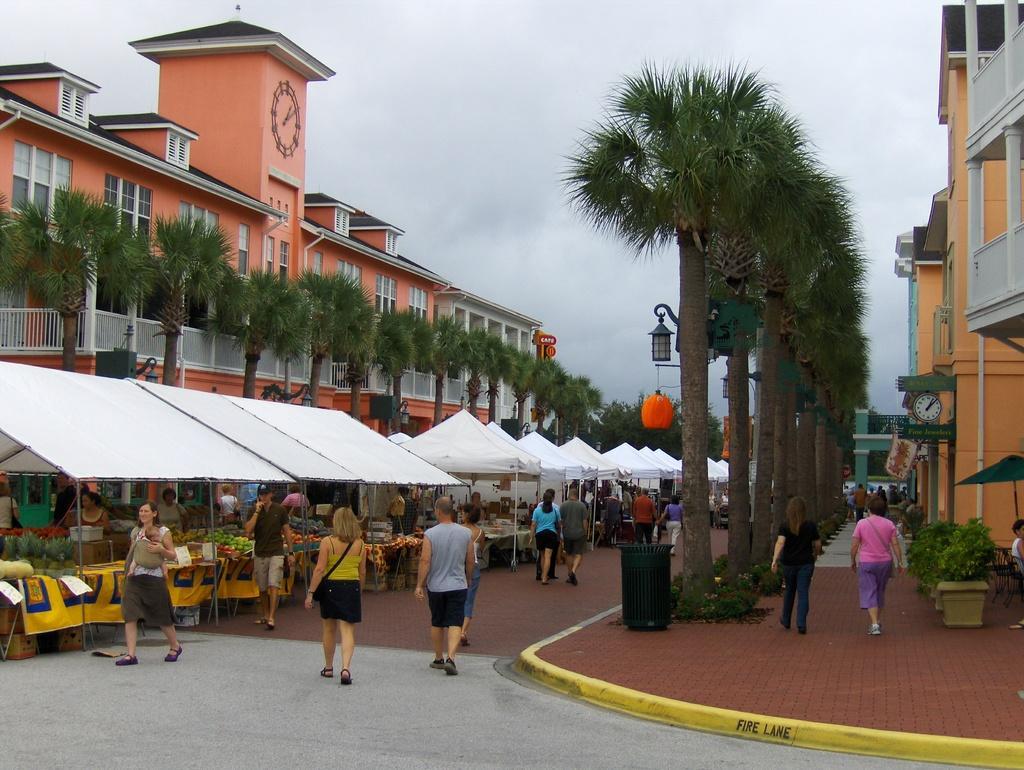Could you give a brief overview of what you see in this image? In this picture we can see there are groups of people walking on the walkway. On the left side of the people, there are some objects in the stalls. On the right side of the people, there are plants, a dustbin and some objects. On the left and right side of the stalls, there are trees, street lights and buildings. At the top of the image, there is the cloudy sky. 